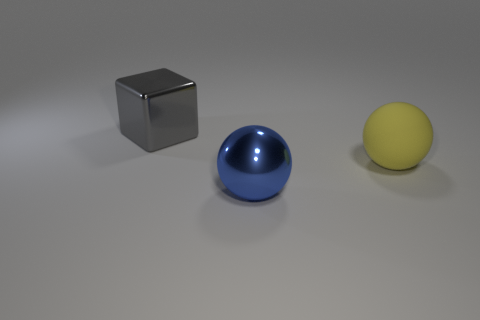Add 1 small brown shiny cubes. How many objects exist? 4 Subtract all cubes. How many objects are left? 2 Add 1 big yellow objects. How many big yellow objects are left? 2 Add 1 tiny gray matte cylinders. How many tiny gray matte cylinders exist? 1 Subtract 0 cyan cylinders. How many objects are left? 3 Subtract all yellow things. Subtract all metal things. How many objects are left? 0 